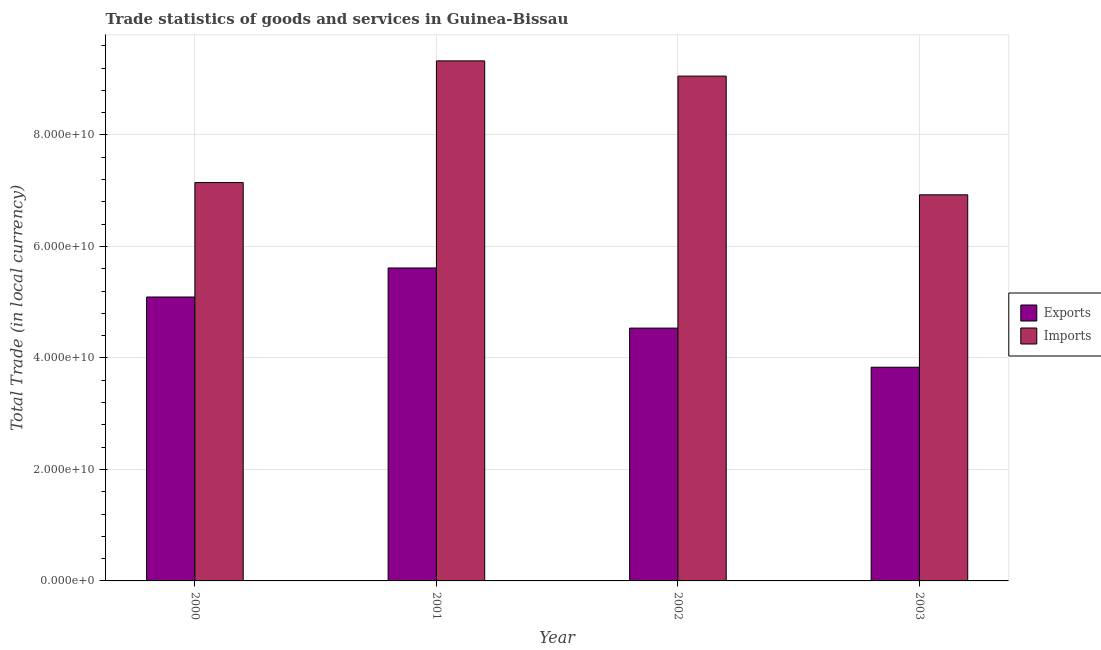How many different coloured bars are there?
Provide a succinct answer. 2. Are the number of bars per tick equal to the number of legend labels?
Make the answer very short. Yes. How many bars are there on the 4th tick from the left?
Your response must be concise. 2. How many bars are there on the 2nd tick from the right?
Make the answer very short. 2. What is the label of the 1st group of bars from the left?
Provide a succinct answer. 2000. In how many cases, is the number of bars for a given year not equal to the number of legend labels?
Provide a short and direct response. 0. What is the export of goods and services in 2001?
Ensure brevity in your answer.  5.61e+1. Across all years, what is the maximum imports of goods and services?
Give a very brief answer. 9.33e+1. Across all years, what is the minimum imports of goods and services?
Provide a succinct answer. 6.93e+1. In which year was the export of goods and services minimum?
Provide a succinct answer. 2003. What is the total imports of goods and services in the graph?
Make the answer very short. 3.25e+11. What is the difference between the imports of goods and services in 2000 and that in 2003?
Your response must be concise. 2.20e+09. What is the difference between the export of goods and services in 2000 and the imports of goods and services in 2003?
Provide a succinct answer. 1.26e+1. What is the average imports of goods and services per year?
Offer a terse response. 8.11e+1. In the year 2001, what is the difference between the imports of goods and services and export of goods and services?
Make the answer very short. 0. In how many years, is the export of goods and services greater than 32000000000 LCU?
Your response must be concise. 4. What is the ratio of the export of goods and services in 2000 to that in 2003?
Offer a terse response. 1.33. Is the export of goods and services in 2001 less than that in 2002?
Ensure brevity in your answer.  No. What is the difference between the highest and the second highest export of goods and services?
Your answer should be very brief. 5.21e+09. What is the difference between the highest and the lowest imports of goods and services?
Give a very brief answer. 2.40e+1. What does the 1st bar from the left in 2000 represents?
Your answer should be compact. Exports. What does the 1st bar from the right in 2000 represents?
Give a very brief answer. Imports. How many bars are there?
Give a very brief answer. 8. Are all the bars in the graph horizontal?
Make the answer very short. No. What is the difference between two consecutive major ticks on the Y-axis?
Your answer should be very brief. 2.00e+1. Does the graph contain any zero values?
Ensure brevity in your answer.  No. Does the graph contain grids?
Provide a short and direct response. Yes. Where does the legend appear in the graph?
Your answer should be very brief. Center right. How are the legend labels stacked?
Your answer should be compact. Vertical. What is the title of the graph?
Give a very brief answer. Trade statistics of goods and services in Guinea-Bissau. What is the label or title of the Y-axis?
Make the answer very short. Total Trade (in local currency). What is the Total Trade (in local currency) in Exports in 2000?
Make the answer very short. 5.09e+1. What is the Total Trade (in local currency) in Imports in 2000?
Ensure brevity in your answer.  7.15e+1. What is the Total Trade (in local currency) of Exports in 2001?
Keep it short and to the point. 5.61e+1. What is the Total Trade (in local currency) in Imports in 2001?
Provide a succinct answer. 9.33e+1. What is the Total Trade (in local currency) of Exports in 2002?
Your response must be concise. 4.53e+1. What is the Total Trade (in local currency) in Imports in 2002?
Make the answer very short. 9.06e+1. What is the Total Trade (in local currency) of Exports in 2003?
Offer a very short reply. 3.83e+1. What is the Total Trade (in local currency) in Imports in 2003?
Provide a succinct answer. 6.93e+1. Across all years, what is the maximum Total Trade (in local currency) of Exports?
Offer a very short reply. 5.61e+1. Across all years, what is the maximum Total Trade (in local currency) in Imports?
Provide a short and direct response. 9.33e+1. Across all years, what is the minimum Total Trade (in local currency) of Exports?
Your answer should be compact. 3.83e+1. Across all years, what is the minimum Total Trade (in local currency) in Imports?
Your response must be concise. 6.93e+1. What is the total Total Trade (in local currency) of Exports in the graph?
Give a very brief answer. 1.91e+11. What is the total Total Trade (in local currency) in Imports in the graph?
Ensure brevity in your answer.  3.25e+11. What is the difference between the Total Trade (in local currency) of Exports in 2000 and that in 2001?
Your answer should be very brief. -5.21e+09. What is the difference between the Total Trade (in local currency) of Imports in 2000 and that in 2001?
Your response must be concise. -2.18e+1. What is the difference between the Total Trade (in local currency) of Exports in 2000 and that in 2002?
Ensure brevity in your answer.  5.58e+09. What is the difference between the Total Trade (in local currency) in Imports in 2000 and that in 2002?
Offer a terse response. -1.91e+1. What is the difference between the Total Trade (in local currency) of Exports in 2000 and that in 2003?
Offer a terse response. 1.26e+1. What is the difference between the Total Trade (in local currency) of Imports in 2000 and that in 2003?
Your answer should be compact. 2.20e+09. What is the difference between the Total Trade (in local currency) in Exports in 2001 and that in 2002?
Your answer should be very brief. 1.08e+1. What is the difference between the Total Trade (in local currency) in Imports in 2001 and that in 2002?
Offer a very short reply. 2.73e+09. What is the difference between the Total Trade (in local currency) in Exports in 2001 and that in 2003?
Your answer should be very brief. 1.78e+1. What is the difference between the Total Trade (in local currency) of Imports in 2001 and that in 2003?
Your answer should be very brief. 2.40e+1. What is the difference between the Total Trade (in local currency) of Exports in 2002 and that in 2003?
Provide a short and direct response. 7.01e+09. What is the difference between the Total Trade (in local currency) in Imports in 2002 and that in 2003?
Offer a terse response. 2.13e+1. What is the difference between the Total Trade (in local currency) of Exports in 2000 and the Total Trade (in local currency) of Imports in 2001?
Give a very brief answer. -4.24e+1. What is the difference between the Total Trade (in local currency) in Exports in 2000 and the Total Trade (in local currency) in Imports in 2002?
Ensure brevity in your answer.  -3.96e+1. What is the difference between the Total Trade (in local currency) of Exports in 2000 and the Total Trade (in local currency) of Imports in 2003?
Your response must be concise. -1.83e+1. What is the difference between the Total Trade (in local currency) of Exports in 2001 and the Total Trade (in local currency) of Imports in 2002?
Keep it short and to the point. -3.44e+1. What is the difference between the Total Trade (in local currency) in Exports in 2001 and the Total Trade (in local currency) in Imports in 2003?
Provide a short and direct response. -1.31e+1. What is the difference between the Total Trade (in local currency) of Exports in 2002 and the Total Trade (in local currency) of Imports in 2003?
Give a very brief answer. -2.39e+1. What is the average Total Trade (in local currency) of Exports per year?
Provide a succinct answer. 4.77e+1. What is the average Total Trade (in local currency) in Imports per year?
Provide a succinct answer. 8.11e+1. In the year 2000, what is the difference between the Total Trade (in local currency) of Exports and Total Trade (in local currency) of Imports?
Give a very brief answer. -2.05e+1. In the year 2001, what is the difference between the Total Trade (in local currency) of Exports and Total Trade (in local currency) of Imports?
Offer a terse response. -3.71e+1. In the year 2002, what is the difference between the Total Trade (in local currency) of Exports and Total Trade (in local currency) of Imports?
Your answer should be compact. -4.52e+1. In the year 2003, what is the difference between the Total Trade (in local currency) of Exports and Total Trade (in local currency) of Imports?
Keep it short and to the point. -3.09e+1. What is the ratio of the Total Trade (in local currency) in Exports in 2000 to that in 2001?
Keep it short and to the point. 0.91. What is the ratio of the Total Trade (in local currency) of Imports in 2000 to that in 2001?
Your response must be concise. 0.77. What is the ratio of the Total Trade (in local currency) of Exports in 2000 to that in 2002?
Offer a very short reply. 1.12. What is the ratio of the Total Trade (in local currency) of Imports in 2000 to that in 2002?
Your answer should be compact. 0.79. What is the ratio of the Total Trade (in local currency) of Exports in 2000 to that in 2003?
Keep it short and to the point. 1.33. What is the ratio of the Total Trade (in local currency) in Imports in 2000 to that in 2003?
Provide a short and direct response. 1.03. What is the ratio of the Total Trade (in local currency) in Exports in 2001 to that in 2002?
Ensure brevity in your answer.  1.24. What is the ratio of the Total Trade (in local currency) of Imports in 2001 to that in 2002?
Offer a very short reply. 1.03. What is the ratio of the Total Trade (in local currency) of Exports in 2001 to that in 2003?
Ensure brevity in your answer.  1.46. What is the ratio of the Total Trade (in local currency) in Imports in 2001 to that in 2003?
Your answer should be compact. 1.35. What is the ratio of the Total Trade (in local currency) in Exports in 2002 to that in 2003?
Make the answer very short. 1.18. What is the ratio of the Total Trade (in local currency) of Imports in 2002 to that in 2003?
Ensure brevity in your answer.  1.31. What is the difference between the highest and the second highest Total Trade (in local currency) of Exports?
Offer a terse response. 5.21e+09. What is the difference between the highest and the second highest Total Trade (in local currency) of Imports?
Offer a terse response. 2.73e+09. What is the difference between the highest and the lowest Total Trade (in local currency) of Exports?
Provide a short and direct response. 1.78e+1. What is the difference between the highest and the lowest Total Trade (in local currency) in Imports?
Your answer should be very brief. 2.40e+1. 